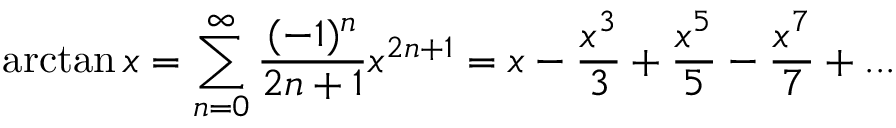Convert formula to latex. <formula><loc_0><loc_0><loc_500><loc_500>\arctan x = \sum _ { n = 0 } ^ { \infty } { \frac { ( - 1 ) ^ { n } } { 2 n + 1 } } x ^ { 2 n + 1 } = x - { \frac { x ^ { 3 } } { 3 } } + { \frac { x ^ { 5 } } { 5 } } - { \frac { x ^ { 7 } } { 7 } } + \dots</formula> 